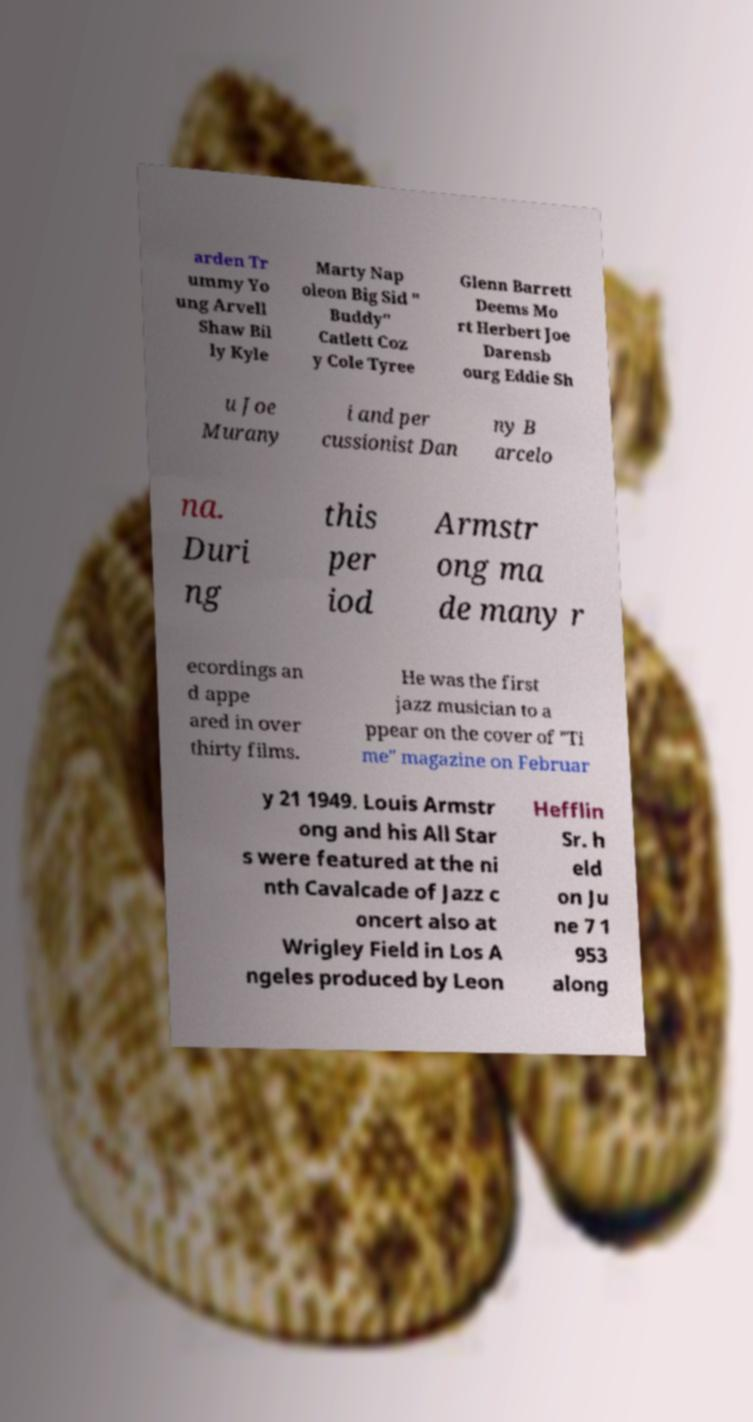Please read and relay the text visible in this image. What does it say? arden Tr ummy Yo ung Arvell Shaw Bil ly Kyle Marty Nap oleon Big Sid " Buddy" Catlett Coz y Cole Tyree Glenn Barrett Deems Mo rt Herbert Joe Darensb ourg Eddie Sh u Joe Murany i and per cussionist Dan ny B arcelo na. Duri ng this per iod Armstr ong ma de many r ecordings an d appe ared in over thirty films. He was the first jazz musician to a ppear on the cover of "Ti me" magazine on Februar y 21 1949. Louis Armstr ong and his All Star s were featured at the ni nth Cavalcade of Jazz c oncert also at Wrigley Field in Los A ngeles produced by Leon Hefflin Sr. h eld on Ju ne 7 1 953 along 